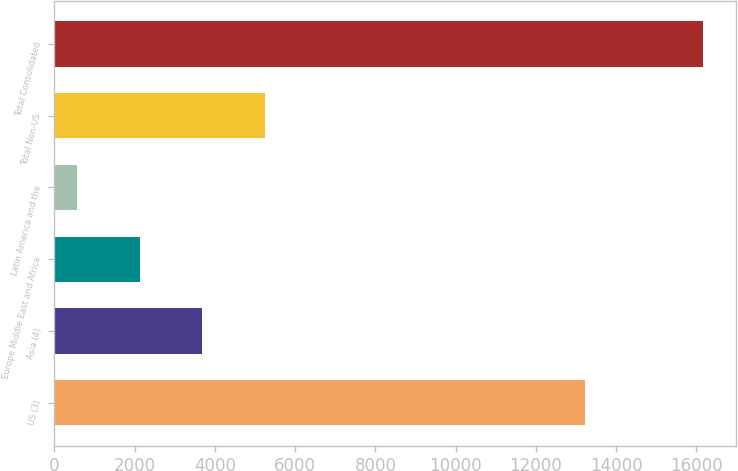Convert chart to OTSL. <chart><loc_0><loc_0><loc_500><loc_500><bar_chart><fcel>US (3)<fcel>Asia (4)<fcel>Europe Middle East and Africa<fcel>Latin America and the<fcel>Total Non-US<fcel>Total Consolidated<nl><fcel>13221<fcel>3687.2<fcel>2126.6<fcel>566<fcel>5247.8<fcel>16172<nl></chart> 